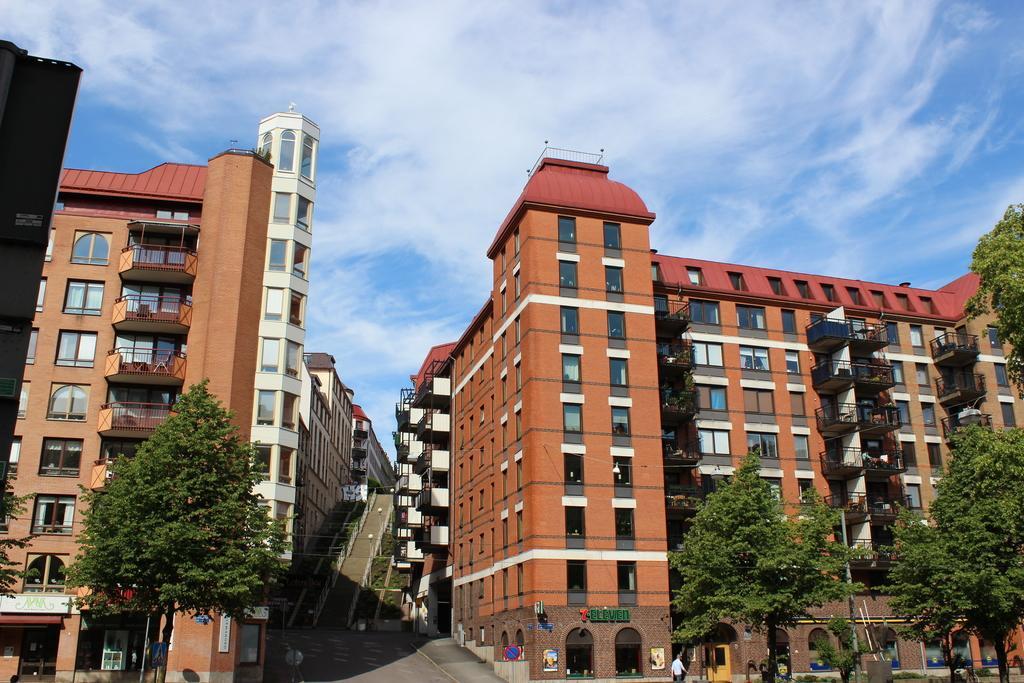Can you describe this image briefly? In this image there are trees and buildings, in the middle of the building there is a road and steps, in the background there is sky. 